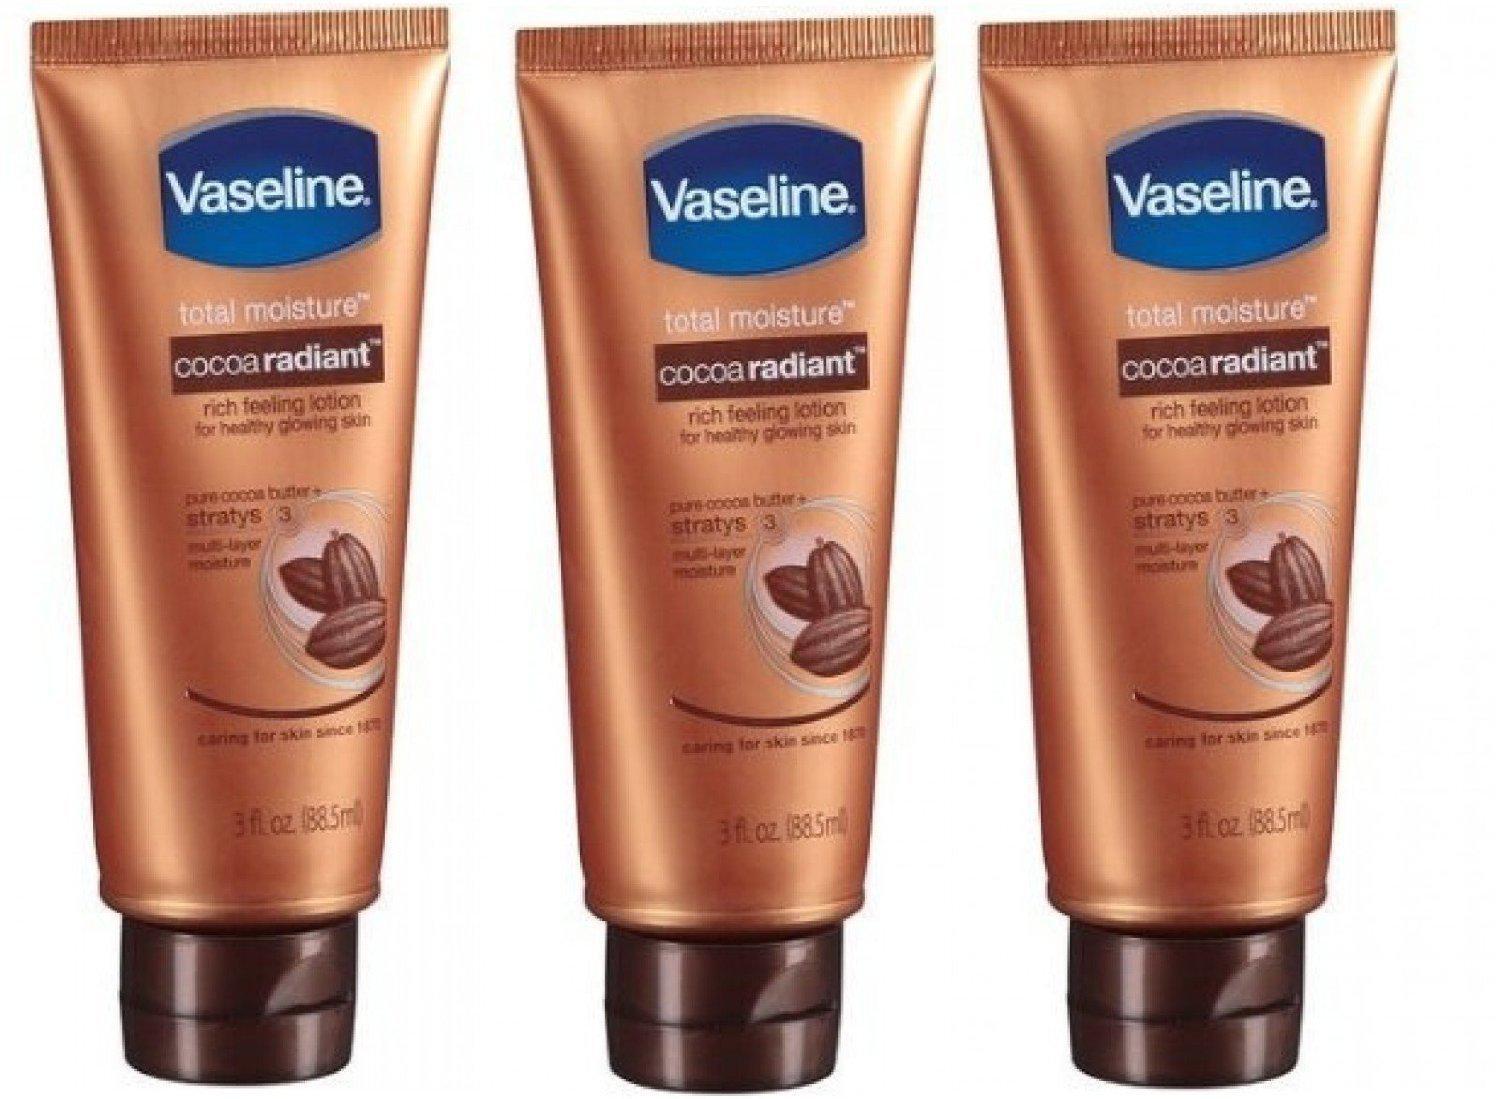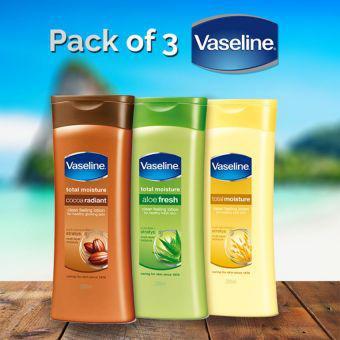The first image is the image on the left, the second image is the image on the right. Given the left and right images, does the statement "The containers in the left image are all brown." hold true? Answer yes or no. Yes. The first image is the image on the left, the second image is the image on the right. Evaluate the accuracy of this statement regarding the images: "Some bottles of Vaseline are still in the package.". Is it true? Answer yes or no. No. 